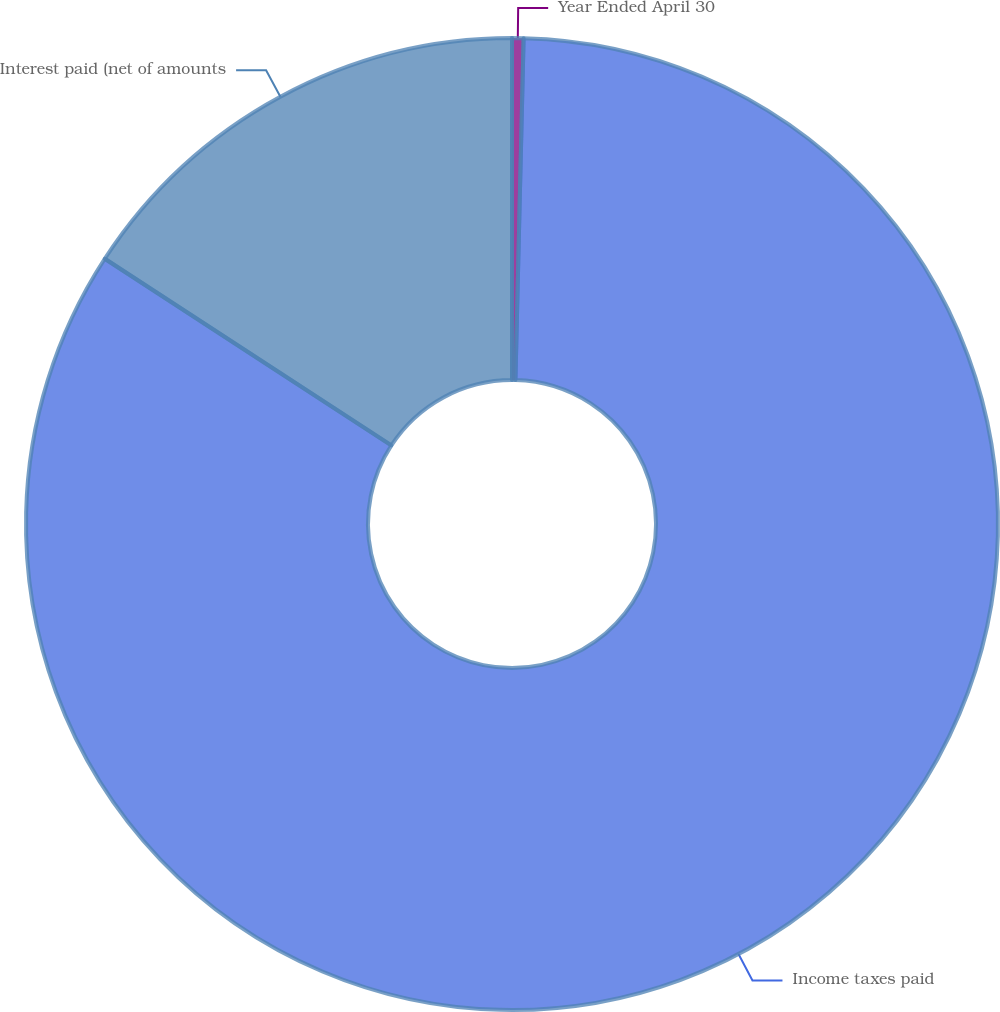<chart> <loc_0><loc_0><loc_500><loc_500><pie_chart><fcel>Year Ended April 30<fcel>Income taxes paid<fcel>Interest paid (net of amounts<nl><fcel>0.38%<fcel>83.8%<fcel>15.81%<nl></chart> 